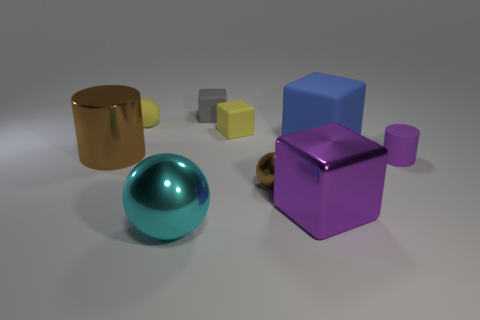Is the color of the metal object to the left of the yellow matte ball the same as the tiny metal object?
Provide a succinct answer. Yes. What number of small yellow matte things have the same shape as the big purple object?
Make the answer very short. 1. Are there an equal number of rubber objects that are left of the big purple thing and rubber cubes?
Keep it short and to the point. Yes. There is a rubber ball that is the same size as the gray rubber object; what is its color?
Your answer should be very brief. Yellow. Are there any other big things of the same shape as the purple rubber thing?
Provide a succinct answer. Yes. The tiny sphere that is behind the large metal cylinder to the left of the brown thing in front of the brown cylinder is made of what material?
Your answer should be compact. Rubber. What number of other objects are the same size as the blue thing?
Your answer should be very brief. 3. The large sphere is what color?
Keep it short and to the point. Cyan. What number of rubber objects are either blue cubes or small red balls?
Your answer should be compact. 1. What size is the sphere in front of the large block that is to the left of the big blue block on the right side of the gray object?
Ensure brevity in your answer.  Large. 